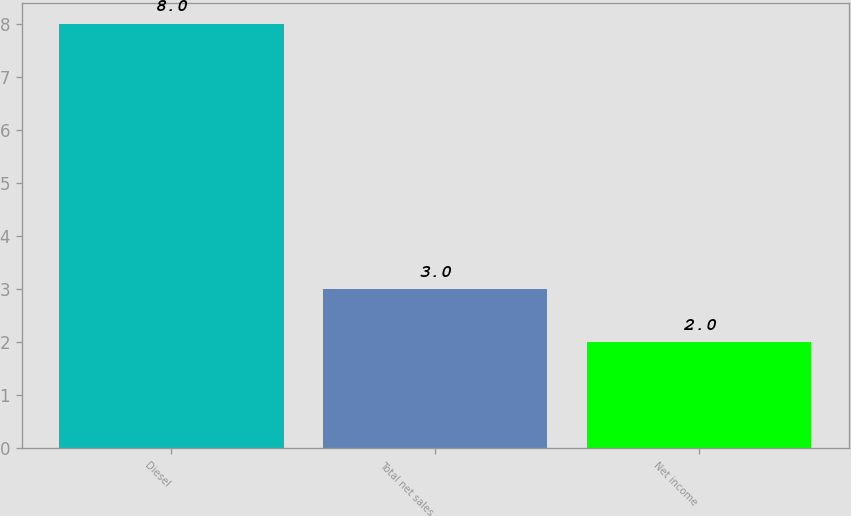<chart> <loc_0><loc_0><loc_500><loc_500><bar_chart><fcel>Diesel<fcel>Total net sales<fcel>Net income<nl><fcel>8<fcel>3<fcel>2<nl></chart> 